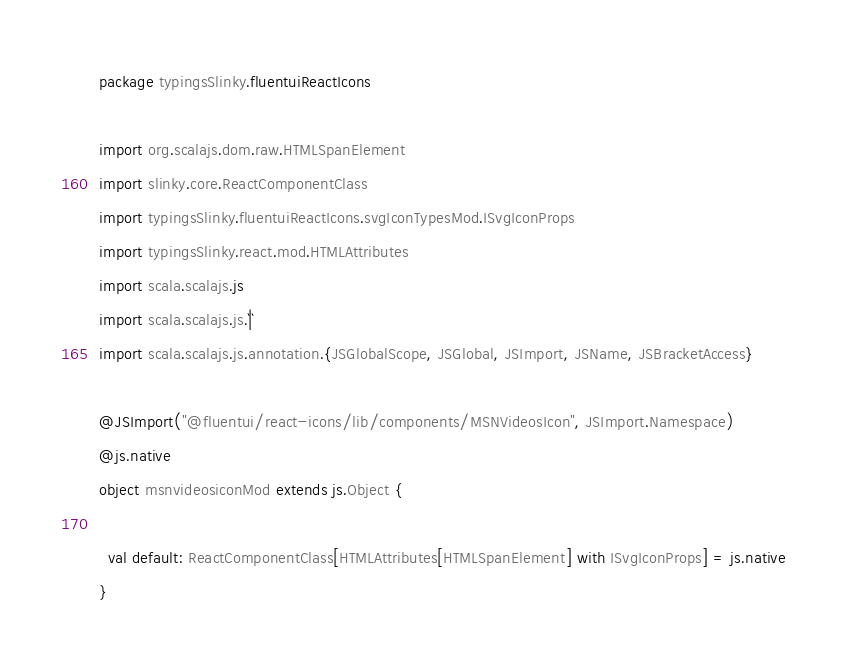Convert code to text. <code><loc_0><loc_0><loc_500><loc_500><_Scala_>package typingsSlinky.fluentuiReactIcons

import org.scalajs.dom.raw.HTMLSpanElement
import slinky.core.ReactComponentClass
import typingsSlinky.fluentuiReactIcons.svgIconTypesMod.ISvgIconProps
import typingsSlinky.react.mod.HTMLAttributes
import scala.scalajs.js
import scala.scalajs.js.`|`
import scala.scalajs.js.annotation.{JSGlobalScope, JSGlobal, JSImport, JSName, JSBracketAccess}

@JSImport("@fluentui/react-icons/lib/components/MSNVideosIcon", JSImport.Namespace)
@js.native
object msnvideosiconMod extends js.Object {
  
  val default: ReactComponentClass[HTMLAttributes[HTMLSpanElement] with ISvgIconProps] = js.native
}
</code> 